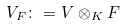Convert formula to latex. <formula><loc_0><loc_0><loc_500><loc_500>V _ { F } \colon = V \otimes _ { K } F</formula> 